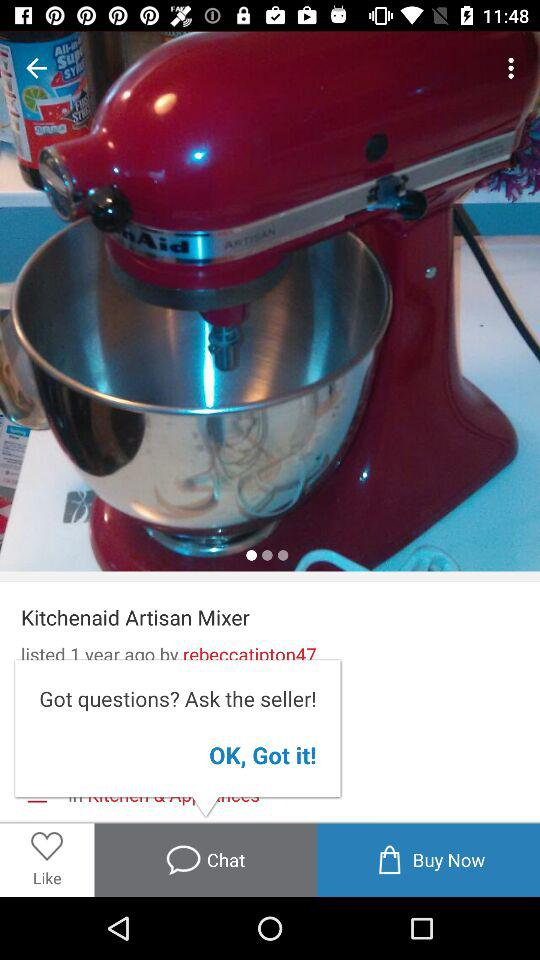What is the name of the product? The name of the product is "Kitchenaid Artisan Mixer". 